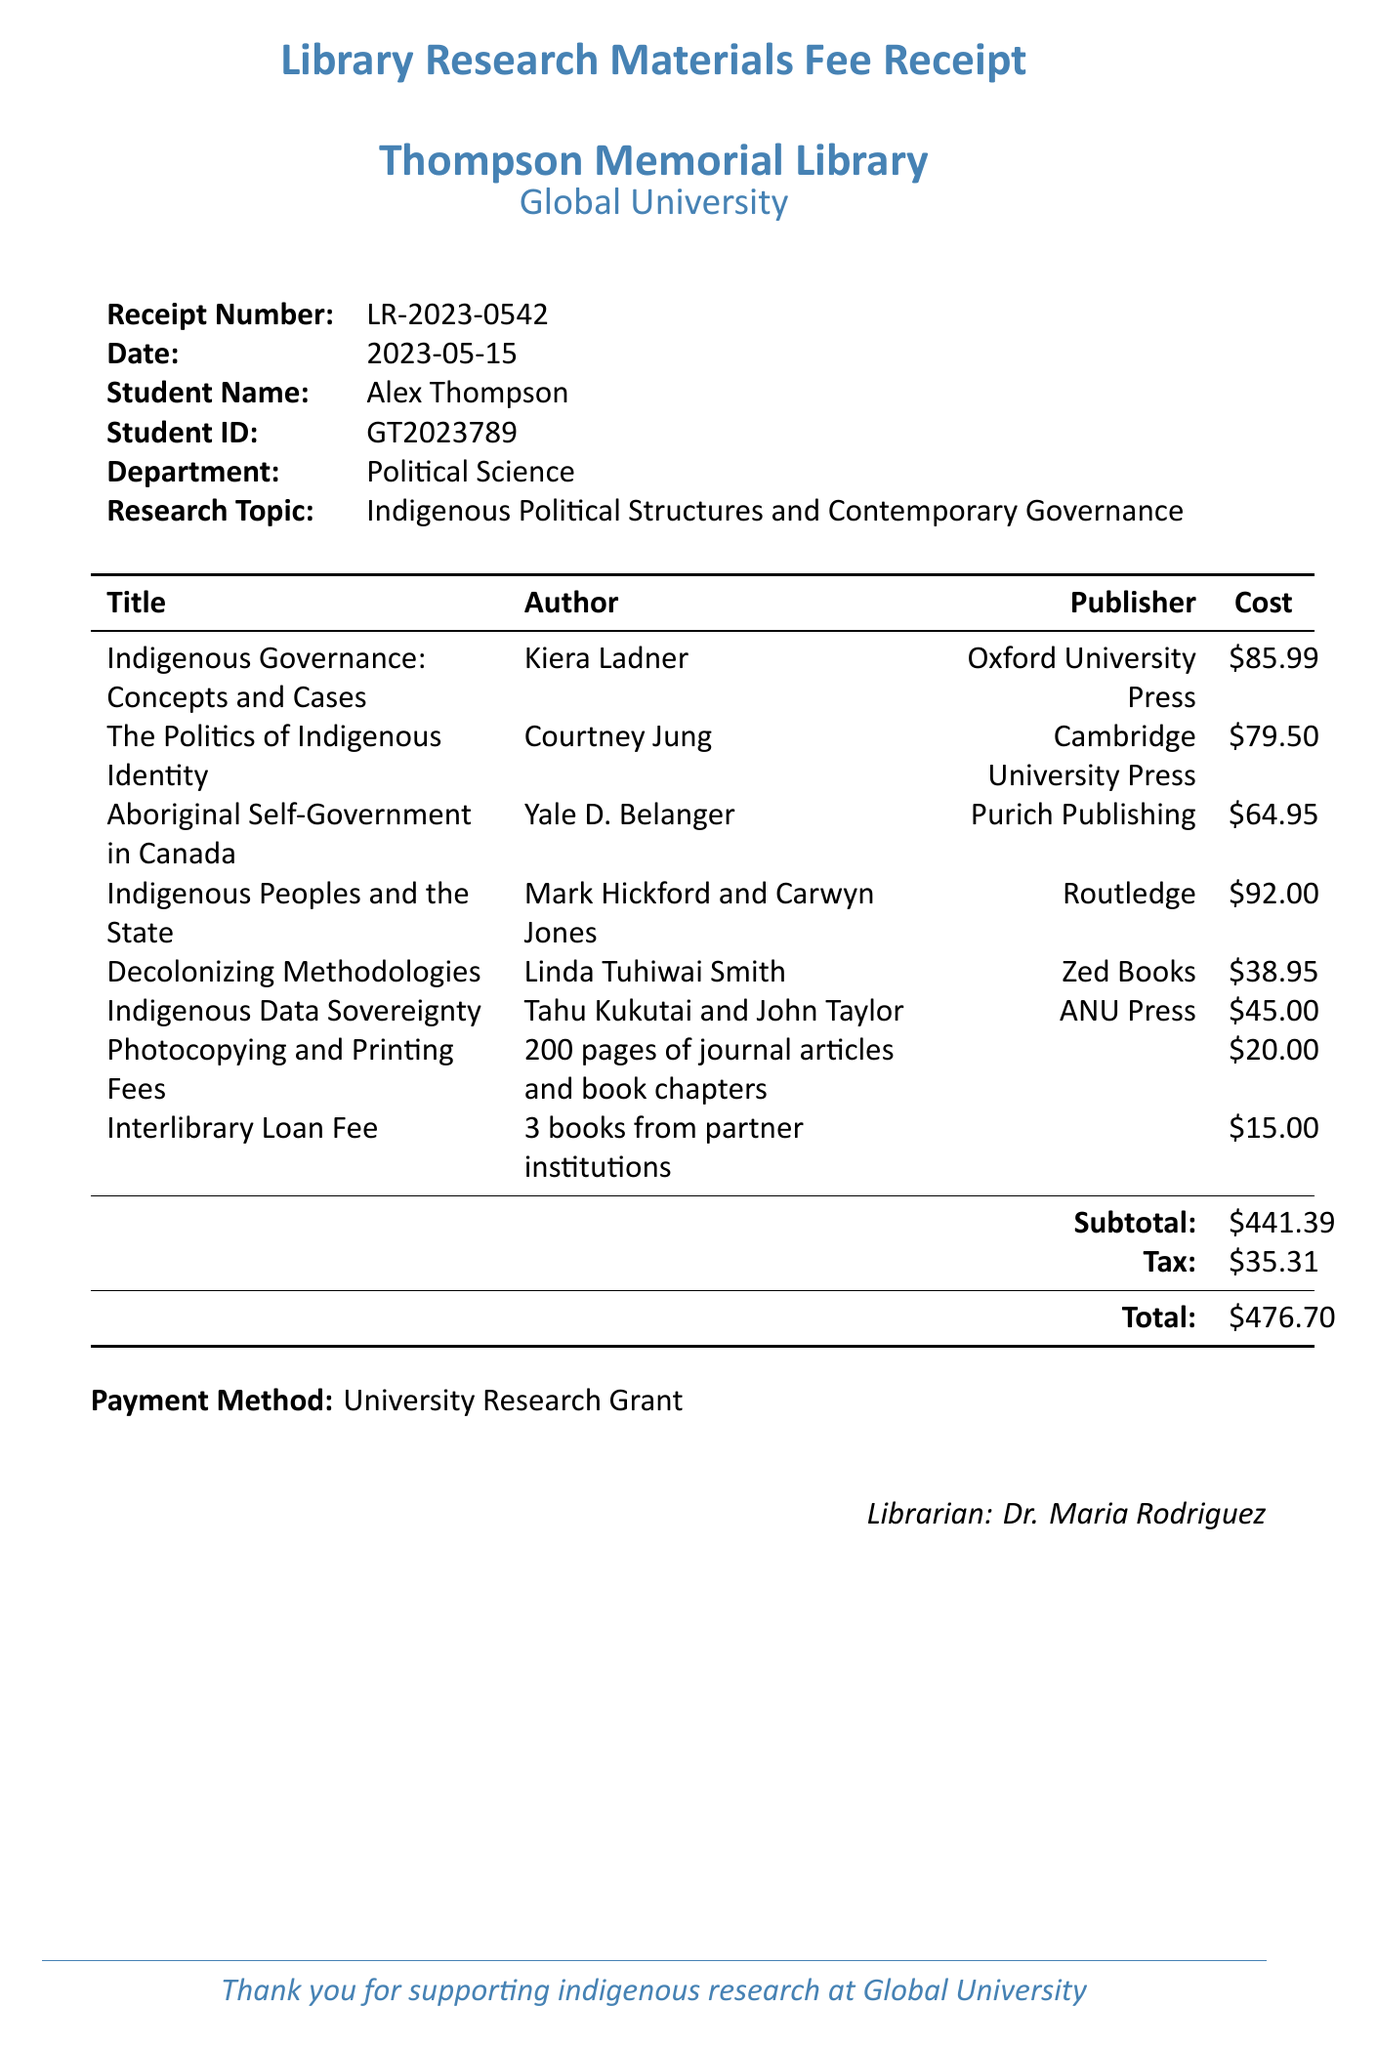What is the receipt number? The receipt number is provided at the top of the document to identify the transaction.
Answer: LR-2023-0542 Who is the student? The student's name is mentioned on the receipt, indicating who made the payment.
Answer: Alex Thompson What is the total amount charged? The total amount is summarized at the bottom of the receipt, indicating the overall fee.
Answer: $476.70 What is the cost of "Indigenous Governance: Concepts and Cases"? The itemized cost of each book is listed, revealing the price for this specific title.
Answer: $85.99 How many books were borrowed through interlibrary loan? The document specifies the number of books that were borrowed, indicating additional costs incurred.
Answer: 3 books What is the subtotal before tax? The subtotal is calculated before tax is applied, reflecting the total of itemized costs.
Answer: $441.39 Who is the librarian? The name of the librarian handling this transaction is included in the receipt for reference.
Answer: Dr. Maria Rodriguez What publishing house published "The Politics of Indigenous Identity"? The publisher's name for each title is listed, allowing identification of the publishing house for this book.
Answer: Cambridge University Press What year was "Decolonizing Methodologies" published? The year of publication is provided for each book, showing when the work was released.
Answer: 2021 